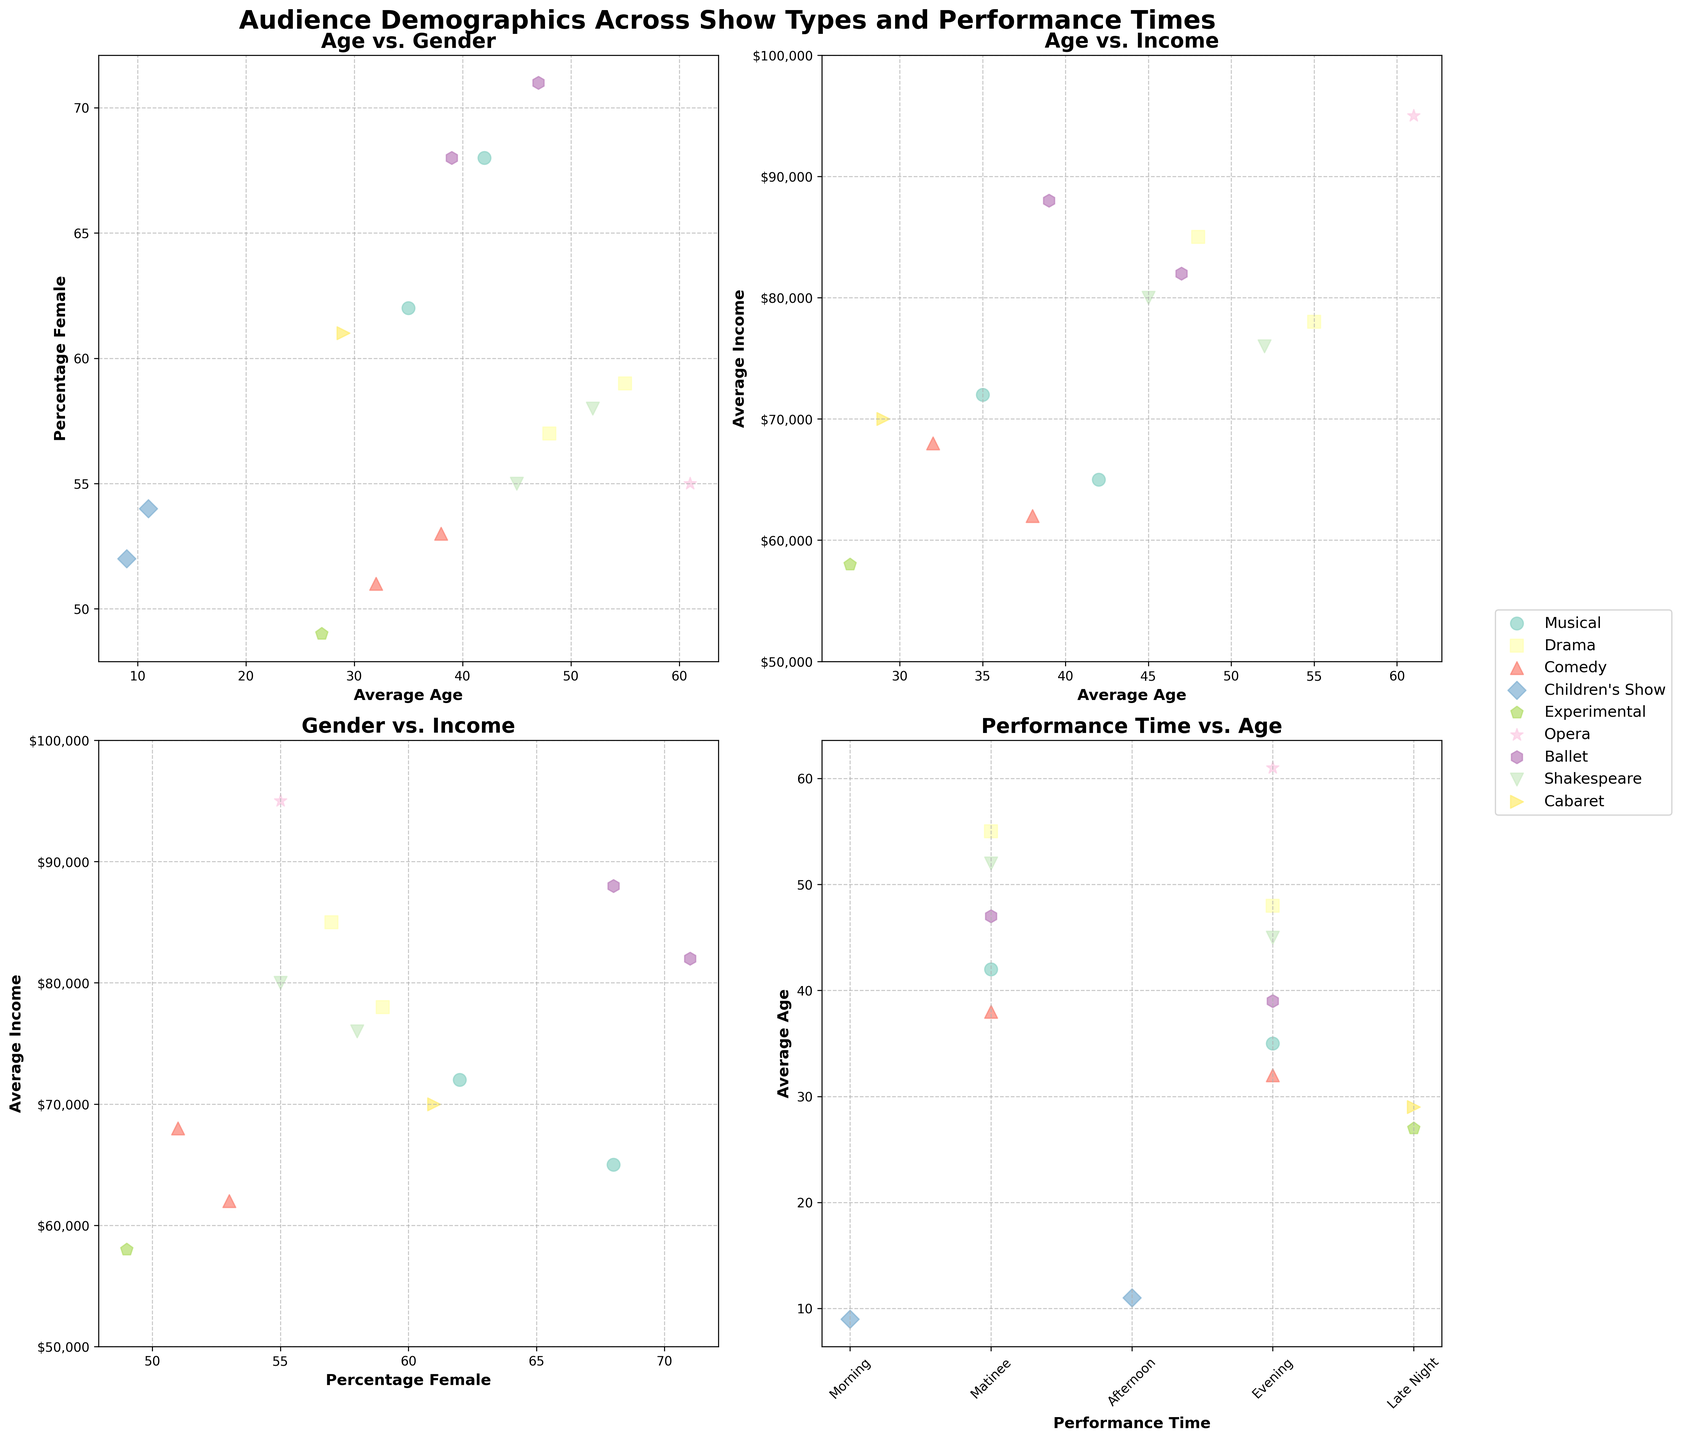Which show type has the oldest average audience in the evening performance? Find the evening performance data points and compare the Average Age for each show type. "Opera" has the oldest average audience with an age of 61.
Answer: Opera What is the title of the entire figure? The title is provided at the top of the figure and reads "Audience Demographics Across Show Types and Performance Times."
Answer: Audience Demographics Across Show Types and Performance Times How does the average income of comedy evening audiences compare to drama matinee audiences? Locate the Comedy (Evening) and Drama (Matinee) data points and compare their average incomes. Comedy (Evening) has an income of 68,000, while Drama (Matinee) has 78,000, so Drama Matinee has a higher average income.
Answer: Drama Matinee Which gender group has the highest representation in the "Performance Time vs. Age" subplot? Observe the gender representation percentage across different show types based on the percentage female. "Ballet Matinee" has the highest female percentage at 71%.
Answer: Ballet Matinee Is there a pattern in the average age of the audience based on performance time? By examining the "Performance Time vs. Age" subplot, note overall age trends for different performance times. Matinee audiences tend to be older compared to evening or late-night audiences.
Answer: Matinees are older How many show types have data points in the "Age vs. Income" subplot? Count unique show types presented and their corresponding data points in the "Age vs. Income" subplot. Some points may be excluded due to missing income data (Children's Shows). There are 9 show types with income data.
Answer: 9 show types What is the relationship between average age and percentage female in musicals? In the "Age vs. Gender" subplot, compare the average age and percentage female for Musicals. Matinee audiences are older (42) with higher female representation (68%) compared to evening audiences (35, 62%).
Answer: Older audiences have more females How does the average income of the "Ballet Evening" audience compare to the "Opera Evening" audience? Compare Ballet (Evening) and Opera (Evening) data points in the "Age vs. Income" subplot. "Ballet Evening" has an average income of 88,000, whereas "Opera Evening" is 95,000.
Answer: Opera is higher In which subplot do we see information about how income varies by gender? The subplot analyzing "Gender vs. Income" deals with how income varies by the percentage of females in the audience.
Answer: Gender vs. Income What performance time has the youngest audience in children’s shows and what age? In the "Performance Time vs. Age" subplot, locate the data for Children's Shows. The morning audience has the youngest age at 9.
Answer: Morning, 9 